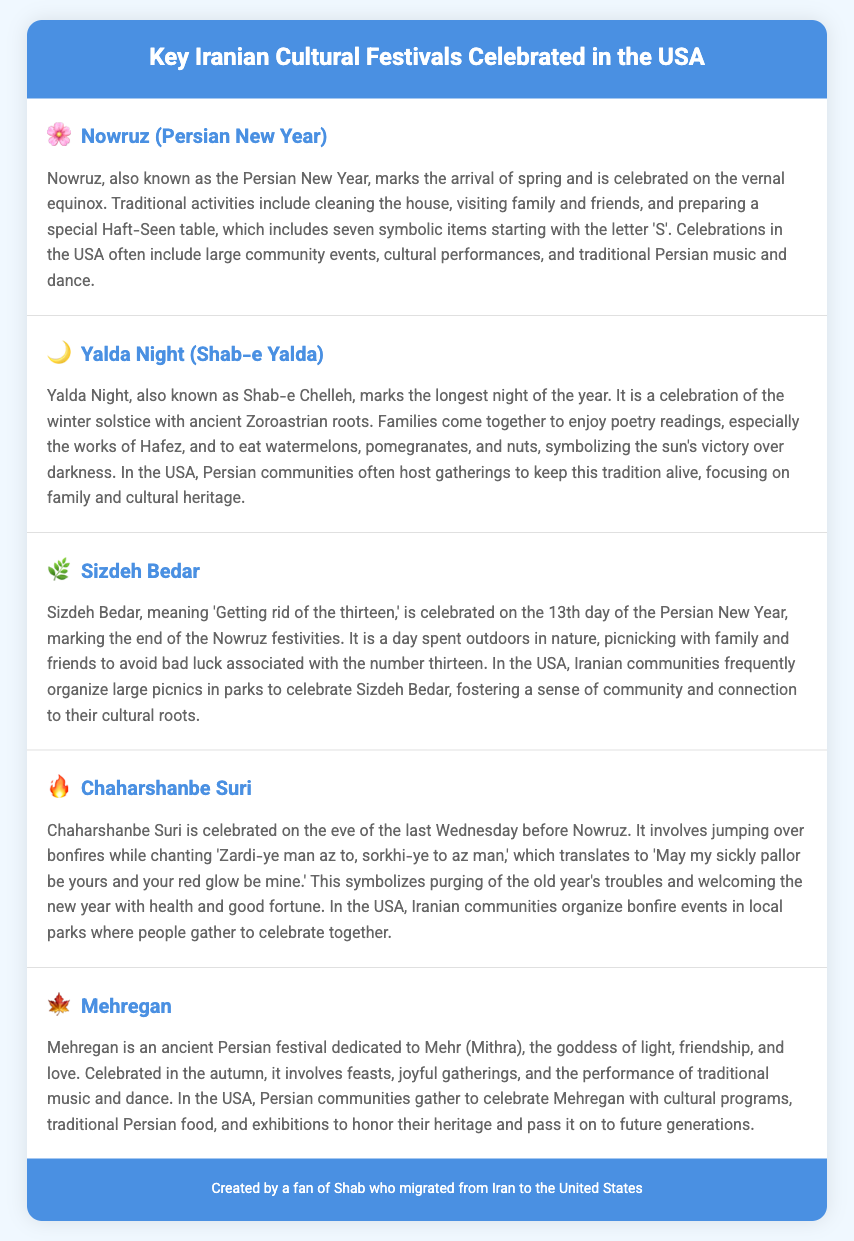What is the first festival listed? The first festival listed is Nowruz, also known as the Persian New Year.
Answer: Nowruz How is Sizdeh Bedar celebrated? Sizdeh Bedar is celebrated by picnicking outdoors with family and friends.
Answer: Picnicking outdoors What does Chaharshanbe Suri involve? Chaharshanbe Suri involves jumping over bonfires while chanting a traditional phrase.
Answer: Jumping over bonfires What season is Mehregan celebrated in? Mehregan is celebrated in the autumn.
Answer: Autumn What is the symbolism of eating watermelons and pomegranates during Yalda Night? They symbolize the sun's victory over darkness.
Answer: Sun's victory over darkness How many key festivals are listed in the document? There are five key festivals listed in the document.
Answer: Five What cultural activity is common during Nowruz celebrations in the USA? Community events, cultural performances, and traditional Persian music and dance.
Answer: Community events What is the purpose of the Haft-Seen table? The Haft-Seen table includes seven symbolic items starting with the letter 'S'.
Answer: Seven symbolic items What is Shab-e Yalda's alternative name? Shab-e Yalda is also known as Shab-e Chelleh.
Answer: Shab-e Chelleh 